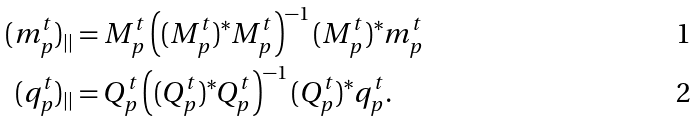Convert formula to latex. <formula><loc_0><loc_0><loc_500><loc_500>( m _ { p } ^ { t } ) _ { | | } & = M _ { p } ^ { t } \left ( ( M _ { p } ^ { t } ) ^ { * } M _ { p } ^ { t } \right ) ^ { - 1 } ( M _ { p } ^ { t } ) ^ { * } m _ { p } ^ { t } \\ ( q _ { p } ^ { t } ) _ { | | } & = Q _ { p } ^ { t } \left ( ( Q _ { p } ^ { t } ) ^ { * } Q _ { p } ^ { t } \right ) ^ { - 1 } ( Q _ { p } ^ { t } ) ^ { * } q _ { p } ^ { t } .</formula> 